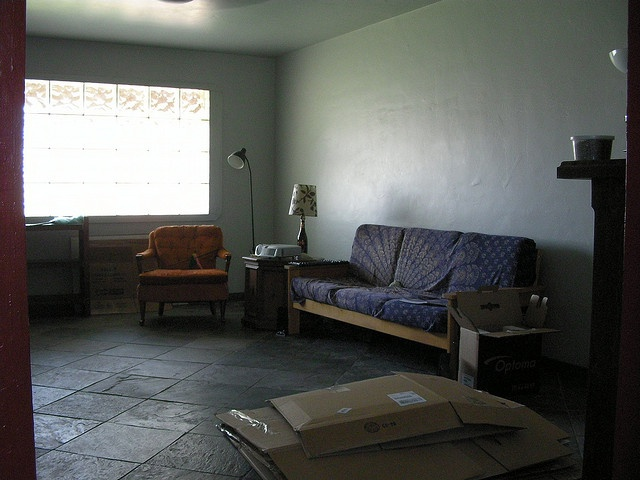Describe the objects in this image and their specific colors. I can see couch in black and gray tones, couch in black, maroon, and gray tones, chair in black, maroon, and gray tones, and cup in black, gray, purple, and darkgray tones in this image. 